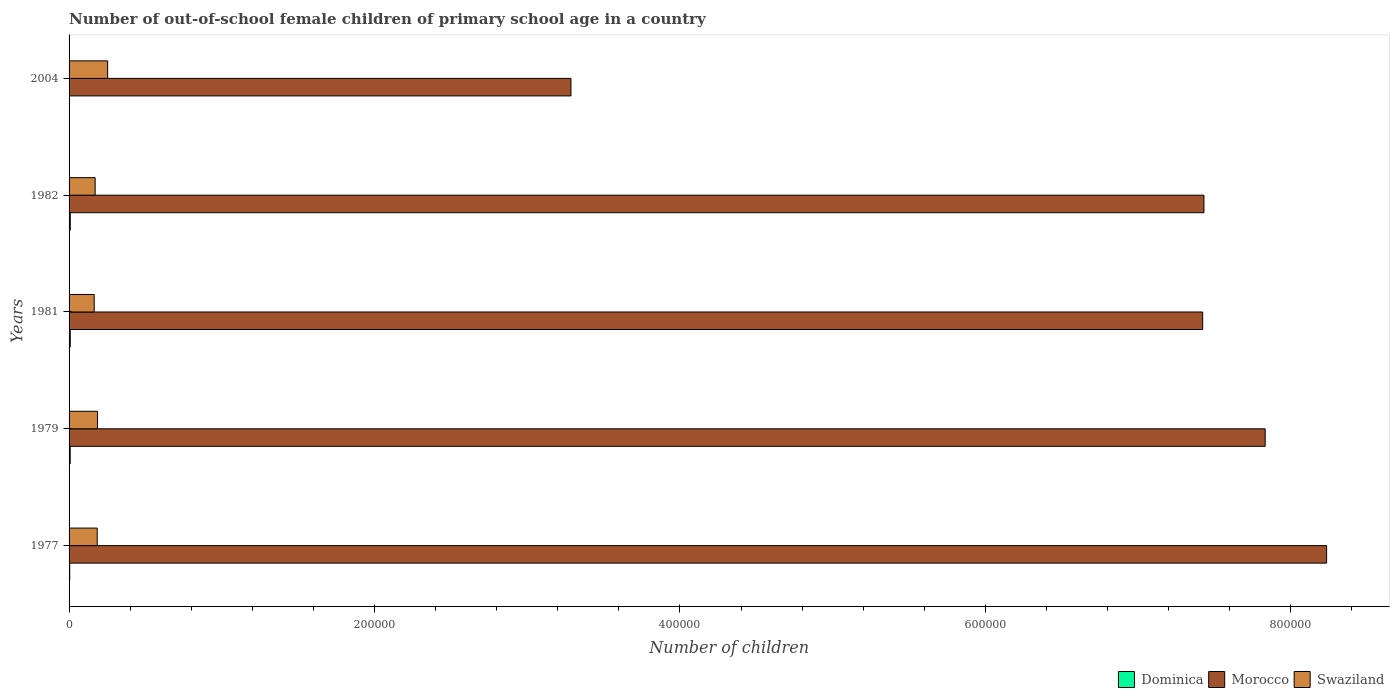How many different coloured bars are there?
Ensure brevity in your answer.  3. Are the number of bars on each tick of the Y-axis equal?
Ensure brevity in your answer.  Yes. How many bars are there on the 5th tick from the bottom?
Offer a terse response. 3. What is the label of the 1st group of bars from the top?
Provide a succinct answer. 2004. In how many cases, is the number of bars for a given year not equal to the number of legend labels?
Provide a short and direct response. 0. What is the number of out-of-school female children in Morocco in 1979?
Make the answer very short. 7.83e+05. Across all years, what is the maximum number of out-of-school female children in Swaziland?
Your answer should be very brief. 2.53e+04. Across all years, what is the minimum number of out-of-school female children in Morocco?
Your answer should be very brief. 3.29e+05. What is the total number of out-of-school female children in Morocco in the graph?
Your answer should be compact. 3.42e+06. What is the difference between the number of out-of-school female children in Morocco in 1979 and that in 1981?
Give a very brief answer. 4.09e+04. What is the difference between the number of out-of-school female children in Morocco in 2004 and the number of out-of-school female children in Swaziland in 1977?
Provide a succinct answer. 3.10e+05. What is the average number of out-of-school female children in Dominica per year?
Keep it short and to the point. 547. In the year 1982, what is the difference between the number of out-of-school female children in Morocco and number of out-of-school female children in Swaziland?
Your answer should be very brief. 7.26e+05. What is the ratio of the number of out-of-school female children in Dominica in 1977 to that in 2004?
Your response must be concise. 42.4. Is the number of out-of-school female children in Swaziland in 1977 less than that in 1981?
Your answer should be compact. No. Is the difference between the number of out-of-school female children in Morocco in 1982 and 2004 greater than the difference between the number of out-of-school female children in Swaziland in 1982 and 2004?
Offer a terse response. Yes. What is the difference between the highest and the second highest number of out-of-school female children in Morocco?
Provide a succinct answer. 4.02e+04. What is the difference between the highest and the lowest number of out-of-school female children in Swaziland?
Make the answer very short. 8783. In how many years, is the number of out-of-school female children in Morocco greater than the average number of out-of-school female children in Morocco taken over all years?
Provide a succinct answer. 4. Is the sum of the number of out-of-school female children in Swaziland in 1982 and 2004 greater than the maximum number of out-of-school female children in Dominica across all years?
Offer a very short reply. Yes. What does the 2nd bar from the top in 2004 represents?
Your response must be concise. Morocco. What does the 3rd bar from the bottom in 1977 represents?
Offer a terse response. Swaziland. How many bars are there?
Make the answer very short. 15. Are all the bars in the graph horizontal?
Offer a terse response. Yes. How many years are there in the graph?
Your response must be concise. 5. What is the difference between two consecutive major ticks on the X-axis?
Provide a short and direct response. 2.00e+05. How are the legend labels stacked?
Your answer should be compact. Horizontal. What is the title of the graph?
Offer a very short reply. Number of out-of-school female children of primary school age in a country. Does "South Africa" appear as one of the legend labels in the graph?
Keep it short and to the point. No. What is the label or title of the X-axis?
Offer a terse response. Number of children. What is the label or title of the Y-axis?
Make the answer very short. Years. What is the Number of children in Dominica in 1977?
Ensure brevity in your answer.  424. What is the Number of children in Morocco in 1977?
Your answer should be compact. 8.23e+05. What is the Number of children of Swaziland in 1977?
Make the answer very short. 1.84e+04. What is the Number of children in Dominica in 1979?
Give a very brief answer. 743. What is the Number of children of Morocco in 1979?
Provide a succinct answer. 7.83e+05. What is the Number of children in Swaziland in 1979?
Give a very brief answer. 1.86e+04. What is the Number of children of Dominica in 1981?
Offer a very short reply. 778. What is the Number of children in Morocco in 1981?
Keep it short and to the point. 7.42e+05. What is the Number of children in Swaziland in 1981?
Give a very brief answer. 1.65e+04. What is the Number of children in Dominica in 1982?
Ensure brevity in your answer.  780. What is the Number of children of Morocco in 1982?
Ensure brevity in your answer.  7.43e+05. What is the Number of children in Swaziland in 1982?
Ensure brevity in your answer.  1.71e+04. What is the Number of children in Dominica in 2004?
Your answer should be compact. 10. What is the Number of children of Morocco in 2004?
Make the answer very short. 3.29e+05. What is the Number of children of Swaziland in 2004?
Offer a terse response. 2.53e+04. Across all years, what is the maximum Number of children of Dominica?
Ensure brevity in your answer.  780. Across all years, what is the maximum Number of children in Morocco?
Your answer should be very brief. 8.23e+05. Across all years, what is the maximum Number of children of Swaziland?
Provide a succinct answer. 2.53e+04. Across all years, what is the minimum Number of children in Dominica?
Your answer should be compact. 10. Across all years, what is the minimum Number of children of Morocco?
Your answer should be very brief. 3.29e+05. Across all years, what is the minimum Number of children in Swaziland?
Offer a terse response. 1.65e+04. What is the total Number of children in Dominica in the graph?
Give a very brief answer. 2735. What is the total Number of children in Morocco in the graph?
Keep it short and to the point. 3.42e+06. What is the total Number of children of Swaziland in the graph?
Give a very brief answer. 9.59e+04. What is the difference between the Number of children in Dominica in 1977 and that in 1979?
Your response must be concise. -319. What is the difference between the Number of children in Morocco in 1977 and that in 1979?
Provide a short and direct response. 4.02e+04. What is the difference between the Number of children in Swaziland in 1977 and that in 1979?
Give a very brief answer. -203. What is the difference between the Number of children of Dominica in 1977 and that in 1981?
Provide a short and direct response. -354. What is the difference between the Number of children of Morocco in 1977 and that in 1981?
Provide a succinct answer. 8.12e+04. What is the difference between the Number of children of Swaziland in 1977 and that in 1981?
Make the answer very short. 1966. What is the difference between the Number of children of Dominica in 1977 and that in 1982?
Give a very brief answer. -356. What is the difference between the Number of children of Morocco in 1977 and that in 1982?
Ensure brevity in your answer.  8.03e+04. What is the difference between the Number of children of Swaziland in 1977 and that in 1982?
Keep it short and to the point. 1357. What is the difference between the Number of children of Dominica in 1977 and that in 2004?
Keep it short and to the point. 414. What is the difference between the Number of children of Morocco in 1977 and that in 2004?
Offer a terse response. 4.95e+05. What is the difference between the Number of children of Swaziland in 1977 and that in 2004?
Provide a succinct answer. -6817. What is the difference between the Number of children of Dominica in 1979 and that in 1981?
Give a very brief answer. -35. What is the difference between the Number of children of Morocco in 1979 and that in 1981?
Make the answer very short. 4.09e+04. What is the difference between the Number of children in Swaziland in 1979 and that in 1981?
Offer a very short reply. 2169. What is the difference between the Number of children in Dominica in 1979 and that in 1982?
Your answer should be very brief. -37. What is the difference between the Number of children in Morocco in 1979 and that in 1982?
Keep it short and to the point. 4.01e+04. What is the difference between the Number of children in Swaziland in 1979 and that in 1982?
Ensure brevity in your answer.  1560. What is the difference between the Number of children of Dominica in 1979 and that in 2004?
Provide a short and direct response. 733. What is the difference between the Number of children of Morocco in 1979 and that in 2004?
Your answer should be compact. 4.55e+05. What is the difference between the Number of children in Swaziland in 1979 and that in 2004?
Ensure brevity in your answer.  -6614. What is the difference between the Number of children of Morocco in 1981 and that in 1982?
Your response must be concise. -844. What is the difference between the Number of children of Swaziland in 1981 and that in 1982?
Your answer should be very brief. -609. What is the difference between the Number of children in Dominica in 1981 and that in 2004?
Make the answer very short. 768. What is the difference between the Number of children of Morocco in 1981 and that in 2004?
Make the answer very short. 4.14e+05. What is the difference between the Number of children in Swaziland in 1981 and that in 2004?
Give a very brief answer. -8783. What is the difference between the Number of children in Dominica in 1982 and that in 2004?
Your answer should be very brief. 770. What is the difference between the Number of children in Morocco in 1982 and that in 2004?
Your answer should be compact. 4.14e+05. What is the difference between the Number of children in Swaziland in 1982 and that in 2004?
Give a very brief answer. -8174. What is the difference between the Number of children in Dominica in 1977 and the Number of children in Morocco in 1979?
Give a very brief answer. -7.83e+05. What is the difference between the Number of children of Dominica in 1977 and the Number of children of Swaziland in 1979?
Give a very brief answer. -1.82e+04. What is the difference between the Number of children in Morocco in 1977 and the Number of children in Swaziland in 1979?
Offer a terse response. 8.05e+05. What is the difference between the Number of children of Dominica in 1977 and the Number of children of Morocco in 1981?
Make the answer very short. -7.42e+05. What is the difference between the Number of children of Dominica in 1977 and the Number of children of Swaziland in 1981?
Provide a short and direct response. -1.60e+04. What is the difference between the Number of children in Morocco in 1977 and the Number of children in Swaziland in 1981?
Provide a short and direct response. 8.07e+05. What is the difference between the Number of children in Dominica in 1977 and the Number of children in Morocco in 1982?
Provide a short and direct response. -7.43e+05. What is the difference between the Number of children in Dominica in 1977 and the Number of children in Swaziland in 1982?
Ensure brevity in your answer.  -1.67e+04. What is the difference between the Number of children in Morocco in 1977 and the Number of children in Swaziland in 1982?
Offer a terse response. 8.06e+05. What is the difference between the Number of children in Dominica in 1977 and the Number of children in Morocco in 2004?
Make the answer very short. -3.28e+05. What is the difference between the Number of children in Dominica in 1977 and the Number of children in Swaziland in 2004?
Make the answer very short. -2.48e+04. What is the difference between the Number of children of Morocco in 1977 and the Number of children of Swaziland in 2004?
Keep it short and to the point. 7.98e+05. What is the difference between the Number of children in Dominica in 1979 and the Number of children in Morocco in 1981?
Offer a very short reply. -7.41e+05. What is the difference between the Number of children in Dominica in 1979 and the Number of children in Swaziland in 1981?
Give a very brief answer. -1.57e+04. What is the difference between the Number of children of Morocco in 1979 and the Number of children of Swaziland in 1981?
Provide a succinct answer. 7.67e+05. What is the difference between the Number of children in Dominica in 1979 and the Number of children in Morocco in 1982?
Your answer should be compact. -7.42e+05. What is the difference between the Number of children of Dominica in 1979 and the Number of children of Swaziland in 1982?
Make the answer very short. -1.63e+04. What is the difference between the Number of children of Morocco in 1979 and the Number of children of Swaziland in 1982?
Your answer should be very brief. 7.66e+05. What is the difference between the Number of children of Dominica in 1979 and the Number of children of Morocco in 2004?
Ensure brevity in your answer.  -3.28e+05. What is the difference between the Number of children in Dominica in 1979 and the Number of children in Swaziland in 2004?
Your answer should be very brief. -2.45e+04. What is the difference between the Number of children of Morocco in 1979 and the Number of children of Swaziland in 2004?
Offer a very short reply. 7.58e+05. What is the difference between the Number of children of Dominica in 1981 and the Number of children of Morocco in 1982?
Keep it short and to the point. -7.42e+05. What is the difference between the Number of children in Dominica in 1981 and the Number of children in Swaziland in 1982?
Offer a terse response. -1.63e+04. What is the difference between the Number of children in Morocco in 1981 and the Number of children in Swaziland in 1982?
Your answer should be compact. 7.25e+05. What is the difference between the Number of children of Dominica in 1981 and the Number of children of Morocco in 2004?
Ensure brevity in your answer.  -3.28e+05. What is the difference between the Number of children in Dominica in 1981 and the Number of children in Swaziland in 2004?
Offer a terse response. -2.45e+04. What is the difference between the Number of children of Morocco in 1981 and the Number of children of Swaziland in 2004?
Offer a very short reply. 7.17e+05. What is the difference between the Number of children of Dominica in 1982 and the Number of children of Morocco in 2004?
Keep it short and to the point. -3.28e+05. What is the difference between the Number of children in Dominica in 1982 and the Number of children in Swaziland in 2004?
Your answer should be very brief. -2.45e+04. What is the difference between the Number of children in Morocco in 1982 and the Number of children in Swaziland in 2004?
Make the answer very short. 7.18e+05. What is the average Number of children in Dominica per year?
Offer a very short reply. 547. What is the average Number of children of Morocco per year?
Provide a short and direct response. 6.84e+05. What is the average Number of children in Swaziland per year?
Offer a terse response. 1.92e+04. In the year 1977, what is the difference between the Number of children in Dominica and Number of children in Morocco?
Ensure brevity in your answer.  -8.23e+05. In the year 1977, what is the difference between the Number of children of Dominica and Number of children of Swaziland?
Offer a very short reply. -1.80e+04. In the year 1977, what is the difference between the Number of children of Morocco and Number of children of Swaziland?
Ensure brevity in your answer.  8.05e+05. In the year 1979, what is the difference between the Number of children in Dominica and Number of children in Morocco?
Make the answer very short. -7.82e+05. In the year 1979, what is the difference between the Number of children in Dominica and Number of children in Swaziland?
Provide a succinct answer. -1.79e+04. In the year 1979, what is the difference between the Number of children in Morocco and Number of children in Swaziland?
Provide a short and direct response. 7.65e+05. In the year 1981, what is the difference between the Number of children in Dominica and Number of children in Morocco?
Offer a terse response. -7.41e+05. In the year 1981, what is the difference between the Number of children of Dominica and Number of children of Swaziland?
Your response must be concise. -1.57e+04. In the year 1981, what is the difference between the Number of children in Morocco and Number of children in Swaziland?
Give a very brief answer. 7.26e+05. In the year 1982, what is the difference between the Number of children of Dominica and Number of children of Morocco?
Give a very brief answer. -7.42e+05. In the year 1982, what is the difference between the Number of children in Dominica and Number of children in Swaziland?
Your response must be concise. -1.63e+04. In the year 1982, what is the difference between the Number of children in Morocco and Number of children in Swaziland?
Give a very brief answer. 7.26e+05. In the year 2004, what is the difference between the Number of children of Dominica and Number of children of Morocco?
Provide a short and direct response. -3.29e+05. In the year 2004, what is the difference between the Number of children of Dominica and Number of children of Swaziland?
Keep it short and to the point. -2.52e+04. In the year 2004, what is the difference between the Number of children of Morocco and Number of children of Swaziland?
Give a very brief answer. 3.03e+05. What is the ratio of the Number of children in Dominica in 1977 to that in 1979?
Give a very brief answer. 0.57. What is the ratio of the Number of children of Morocco in 1977 to that in 1979?
Keep it short and to the point. 1.05. What is the ratio of the Number of children in Dominica in 1977 to that in 1981?
Offer a very short reply. 0.55. What is the ratio of the Number of children of Morocco in 1977 to that in 1981?
Offer a very short reply. 1.11. What is the ratio of the Number of children of Swaziland in 1977 to that in 1981?
Provide a succinct answer. 1.12. What is the ratio of the Number of children of Dominica in 1977 to that in 1982?
Ensure brevity in your answer.  0.54. What is the ratio of the Number of children of Morocco in 1977 to that in 1982?
Offer a very short reply. 1.11. What is the ratio of the Number of children in Swaziland in 1977 to that in 1982?
Ensure brevity in your answer.  1.08. What is the ratio of the Number of children of Dominica in 1977 to that in 2004?
Your answer should be very brief. 42.4. What is the ratio of the Number of children in Morocco in 1977 to that in 2004?
Make the answer very short. 2.51. What is the ratio of the Number of children of Swaziland in 1977 to that in 2004?
Offer a terse response. 0.73. What is the ratio of the Number of children in Dominica in 1979 to that in 1981?
Your response must be concise. 0.95. What is the ratio of the Number of children of Morocco in 1979 to that in 1981?
Make the answer very short. 1.06. What is the ratio of the Number of children in Swaziland in 1979 to that in 1981?
Make the answer very short. 1.13. What is the ratio of the Number of children in Dominica in 1979 to that in 1982?
Your response must be concise. 0.95. What is the ratio of the Number of children in Morocco in 1979 to that in 1982?
Give a very brief answer. 1.05. What is the ratio of the Number of children of Swaziland in 1979 to that in 1982?
Ensure brevity in your answer.  1.09. What is the ratio of the Number of children in Dominica in 1979 to that in 2004?
Keep it short and to the point. 74.3. What is the ratio of the Number of children in Morocco in 1979 to that in 2004?
Ensure brevity in your answer.  2.38. What is the ratio of the Number of children in Swaziland in 1979 to that in 2004?
Your answer should be very brief. 0.74. What is the ratio of the Number of children in Dominica in 1981 to that in 1982?
Keep it short and to the point. 1. What is the ratio of the Number of children of Dominica in 1981 to that in 2004?
Give a very brief answer. 77.8. What is the ratio of the Number of children in Morocco in 1981 to that in 2004?
Ensure brevity in your answer.  2.26. What is the ratio of the Number of children of Swaziland in 1981 to that in 2004?
Keep it short and to the point. 0.65. What is the ratio of the Number of children of Morocco in 1982 to that in 2004?
Provide a short and direct response. 2.26. What is the ratio of the Number of children in Swaziland in 1982 to that in 2004?
Your response must be concise. 0.68. What is the difference between the highest and the second highest Number of children of Dominica?
Give a very brief answer. 2. What is the difference between the highest and the second highest Number of children in Morocco?
Provide a short and direct response. 4.02e+04. What is the difference between the highest and the second highest Number of children in Swaziland?
Your response must be concise. 6614. What is the difference between the highest and the lowest Number of children in Dominica?
Your response must be concise. 770. What is the difference between the highest and the lowest Number of children of Morocco?
Your answer should be very brief. 4.95e+05. What is the difference between the highest and the lowest Number of children in Swaziland?
Your answer should be compact. 8783. 